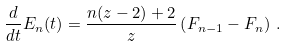Convert formula to latex. <formula><loc_0><loc_0><loc_500><loc_500>\frac { d } { d t } E _ { n } ( t ) = \frac { n ( z - 2 ) + 2 } { z } \left ( F _ { n - 1 } - F _ { n } \right ) \, .</formula> 